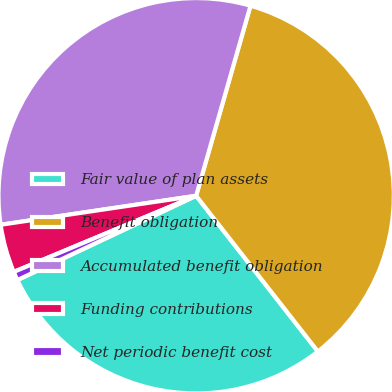Convert chart to OTSL. <chart><loc_0><loc_0><loc_500><loc_500><pie_chart><fcel>Fair value of plan assets<fcel>Benefit obligation<fcel>Accumulated benefit obligation<fcel>Funding contributions<fcel>Net periodic benefit cost<nl><fcel>28.55%<fcel>35.01%<fcel>31.78%<fcel>3.95%<fcel>0.72%<nl></chart> 